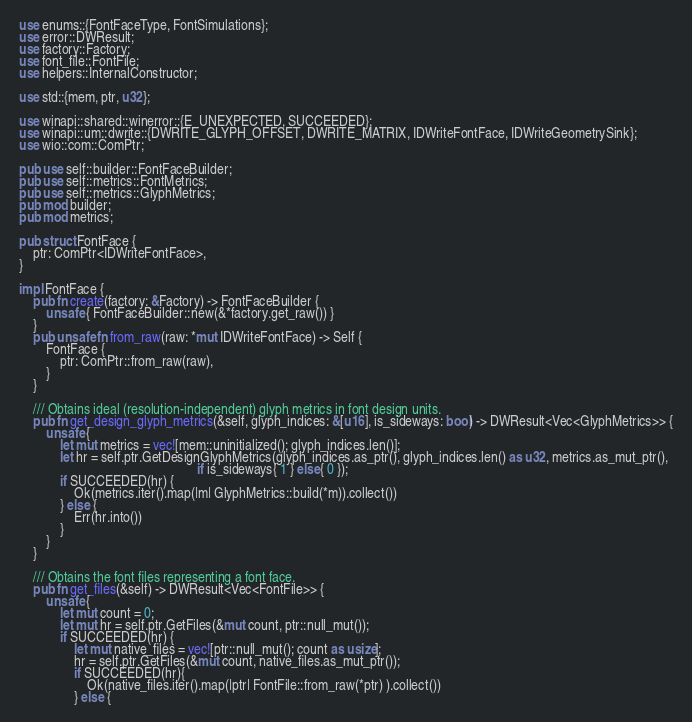Convert code to text. <code><loc_0><loc_0><loc_500><loc_500><_Rust_>use enums::{FontFaceType, FontSimulations};
use error::DWResult;
use factory::Factory;
use font_file::FontFile;
use helpers::InternalConstructor;

use std::{mem, ptr, u32};

use winapi::shared::winerror::{E_UNEXPECTED, SUCCEEDED};
use winapi::um::dwrite::{DWRITE_GLYPH_OFFSET, DWRITE_MATRIX, IDWriteFontFace, IDWriteGeometrySink};
use wio::com::ComPtr;

pub use self::builder::FontFaceBuilder;
pub use self::metrics::FontMetrics;
pub use self::metrics::GlyphMetrics;
pub mod builder;
pub mod metrics;

pub struct FontFace {
    ptr: ComPtr<IDWriteFontFace>,
}

impl FontFace {
    pub fn create(factory: &Factory) -> FontFaceBuilder {
        unsafe { FontFaceBuilder::new(&*factory.get_raw()) }
    }
    pub unsafe fn from_raw(raw: *mut IDWriteFontFace) -> Self {
        FontFace {
            ptr: ComPtr::from_raw(raw),
        }
    }

    /// Obtains ideal (resolution-independent) glyph metrics in font design units. 
    pub fn get_design_glyph_metrics(&self, glyph_indices: &[u16], is_sideways: bool) -> DWResult<Vec<GlyphMetrics>> {
        unsafe {
            let mut metrics = vec![mem::uninitialized(); glyph_indices.len()];
            let hr = self.ptr.GetDesignGlyphMetrics(glyph_indices.as_ptr(), glyph_indices.len() as u32, metrics.as_mut_ptr(), 
                                                    if is_sideways{ 1 } else{ 0 });
            if SUCCEEDED(hr) {
                Ok(metrics.iter().map(|m| GlyphMetrics::build(*m)).collect())
            } else {
                Err(hr.into())
            }
        }
    }

    /// Obtains the font files representing a font face.
    pub fn get_files(&self) -> DWResult<Vec<FontFile>> {
        unsafe {
            let mut count = 0;
            let mut hr = self.ptr.GetFiles(&mut count, ptr::null_mut());
            if SUCCEEDED(hr) {
                let mut native_files = vec![ptr::null_mut(); count as usize];
                hr = self.ptr.GetFiles(&mut count, native_files.as_mut_ptr());
                if SUCCEEDED(hr){
                    Ok(native_files.iter().map(|ptr| FontFile::from_raw(*ptr) ).collect())
                } else {</code> 